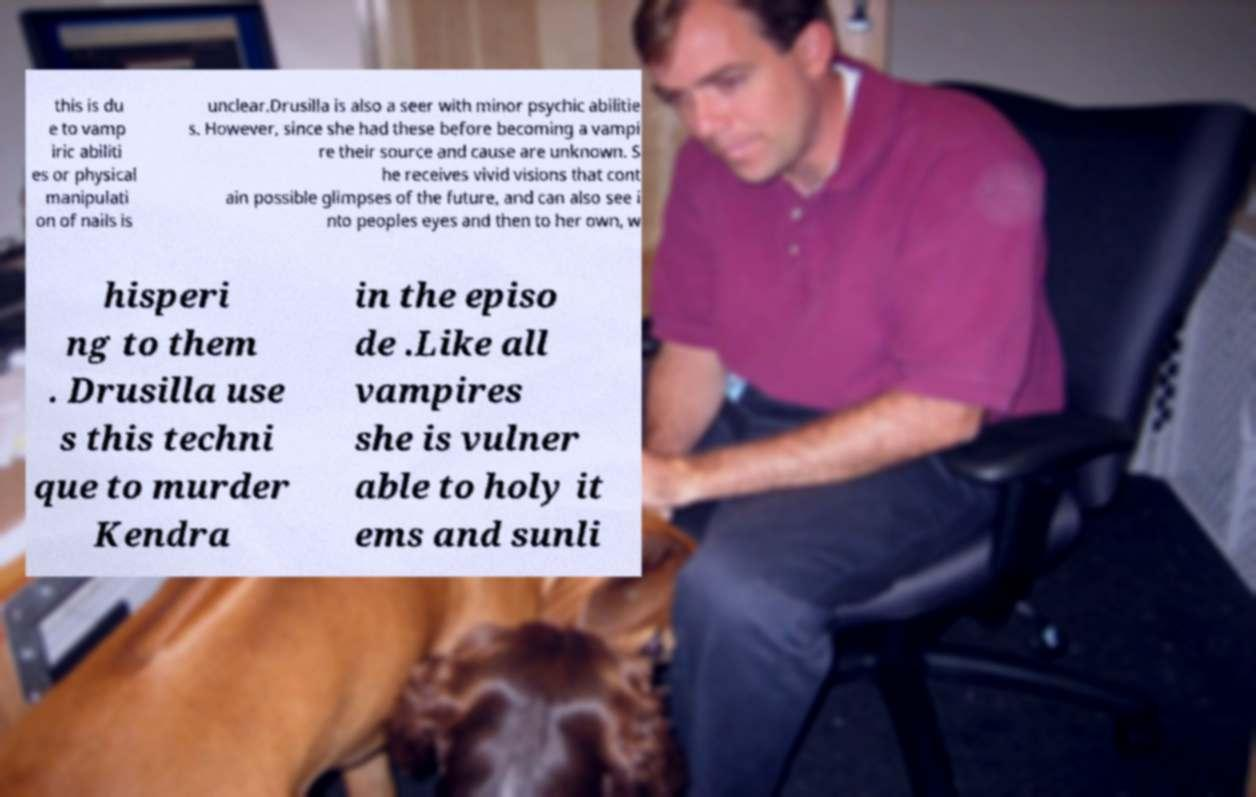Please identify and transcribe the text found in this image. this is du e to vamp iric abiliti es or physical manipulati on of nails is unclear.Drusilla is also a seer with minor psychic abilitie s. However, since she had these before becoming a vampi re their source and cause are unknown. S he receives vivid visions that cont ain possible glimpses of the future, and can also see i nto peoples eyes and then to her own, w hisperi ng to them . Drusilla use s this techni que to murder Kendra in the episo de .Like all vampires she is vulner able to holy it ems and sunli 